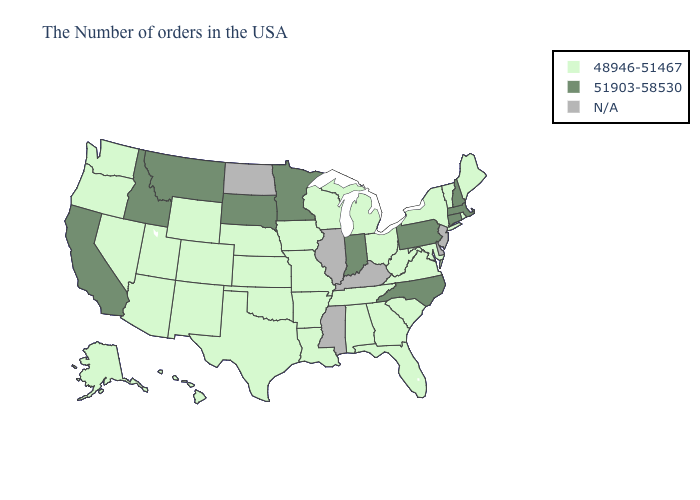What is the value of Minnesota?
Give a very brief answer. 51903-58530. Among the states that border Florida , which have the highest value?
Concise answer only. Georgia, Alabama. Which states have the highest value in the USA?
Concise answer only. Massachusetts, New Hampshire, Connecticut, Pennsylvania, North Carolina, Indiana, Minnesota, South Dakota, Montana, Idaho, California. Does Pennsylvania have the lowest value in the USA?
Be succinct. No. Does South Carolina have the highest value in the South?
Concise answer only. No. What is the highest value in states that border Rhode Island?
Concise answer only. 51903-58530. What is the lowest value in the USA?
Answer briefly. 48946-51467. What is the value of Iowa?
Quick response, please. 48946-51467. Name the states that have a value in the range 51903-58530?
Short answer required. Massachusetts, New Hampshire, Connecticut, Pennsylvania, North Carolina, Indiana, Minnesota, South Dakota, Montana, Idaho, California. Does Virginia have the lowest value in the South?
Short answer required. Yes. Name the states that have a value in the range N/A?
Be succinct. New Jersey, Delaware, Kentucky, Illinois, Mississippi, North Dakota. What is the lowest value in states that border New York?
Be succinct. 48946-51467. Name the states that have a value in the range 51903-58530?
Give a very brief answer. Massachusetts, New Hampshire, Connecticut, Pennsylvania, North Carolina, Indiana, Minnesota, South Dakota, Montana, Idaho, California. Does the first symbol in the legend represent the smallest category?
Be succinct. Yes. 